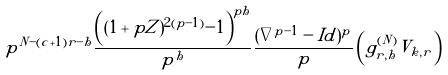Convert formula to latex. <formula><loc_0><loc_0><loc_500><loc_500>p ^ { N - ( c + 1 ) r - h } \frac { \left ( ( 1 + p Z ) ^ { 2 ( p - 1 ) } - 1 \right ) ^ { p h } } { p ^ { h } } \frac { ( \nabla ^ { p - 1 } - I d ) ^ { p } } { p } \left ( g _ { r , h } ^ { ( N ) } V _ { k , r } \right )</formula> 